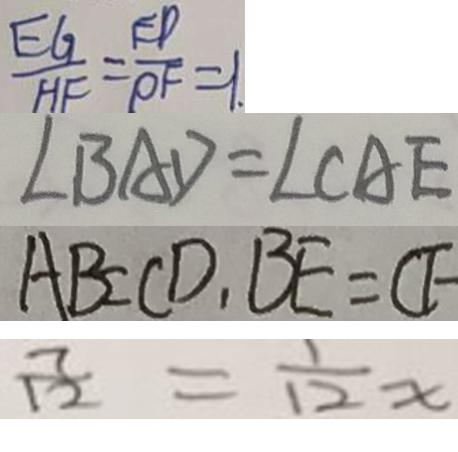Convert formula to latex. <formula><loc_0><loc_0><loc_500><loc_500>\frac { E G } { H F } = \frac { E D } { P F } = 1 . 
 \angle B A D = \angle C A E 
 A B = C D , B E = C F 
 \frac { 7 } { 1 2 } = \frac { 1 } { 1 2 } x</formula> 